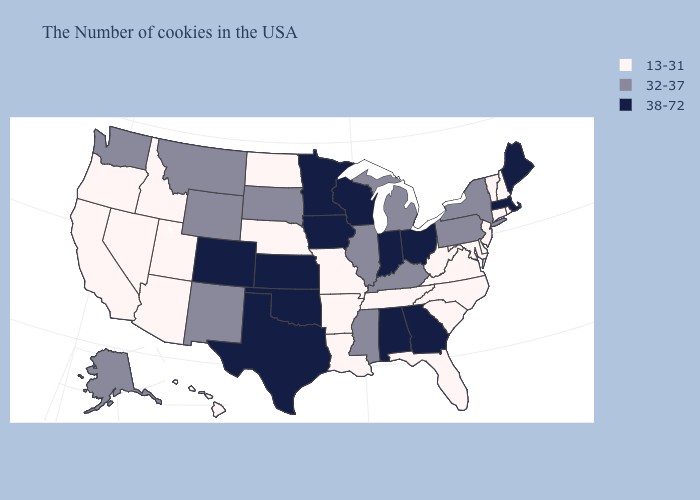Does Michigan have the lowest value in the USA?
Concise answer only. No. Does Iowa have the lowest value in the MidWest?
Quick response, please. No. Among the states that border Virginia , which have the highest value?
Give a very brief answer. Kentucky. What is the value of Alaska?
Answer briefly. 32-37. What is the value of South Dakota?
Give a very brief answer. 32-37. What is the highest value in the USA?
Keep it brief. 38-72. What is the value of Virginia?
Give a very brief answer. 13-31. Does the first symbol in the legend represent the smallest category?
Short answer required. Yes. Name the states that have a value in the range 32-37?
Answer briefly. New York, Pennsylvania, Michigan, Kentucky, Illinois, Mississippi, South Dakota, Wyoming, New Mexico, Montana, Washington, Alaska. Name the states that have a value in the range 13-31?
Quick response, please. Rhode Island, New Hampshire, Vermont, Connecticut, New Jersey, Delaware, Maryland, Virginia, North Carolina, South Carolina, West Virginia, Florida, Tennessee, Louisiana, Missouri, Arkansas, Nebraska, North Dakota, Utah, Arizona, Idaho, Nevada, California, Oregon, Hawaii. Name the states that have a value in the range 38-72?
Concise answer only. Maine, Massachusetts, Ohio, Georgia, Indiana, Alabama, Wisconsin, Minnesota, Iowa, Kansas, Oklahoma, Texas, Colorado. What is the value of West Virginia?
Keep it brief. 13-31. Does Alabama have the highest value in the South?
Quick response, please. Yes. What is the value of Texas?
Give a very brief answer. 38-72. 